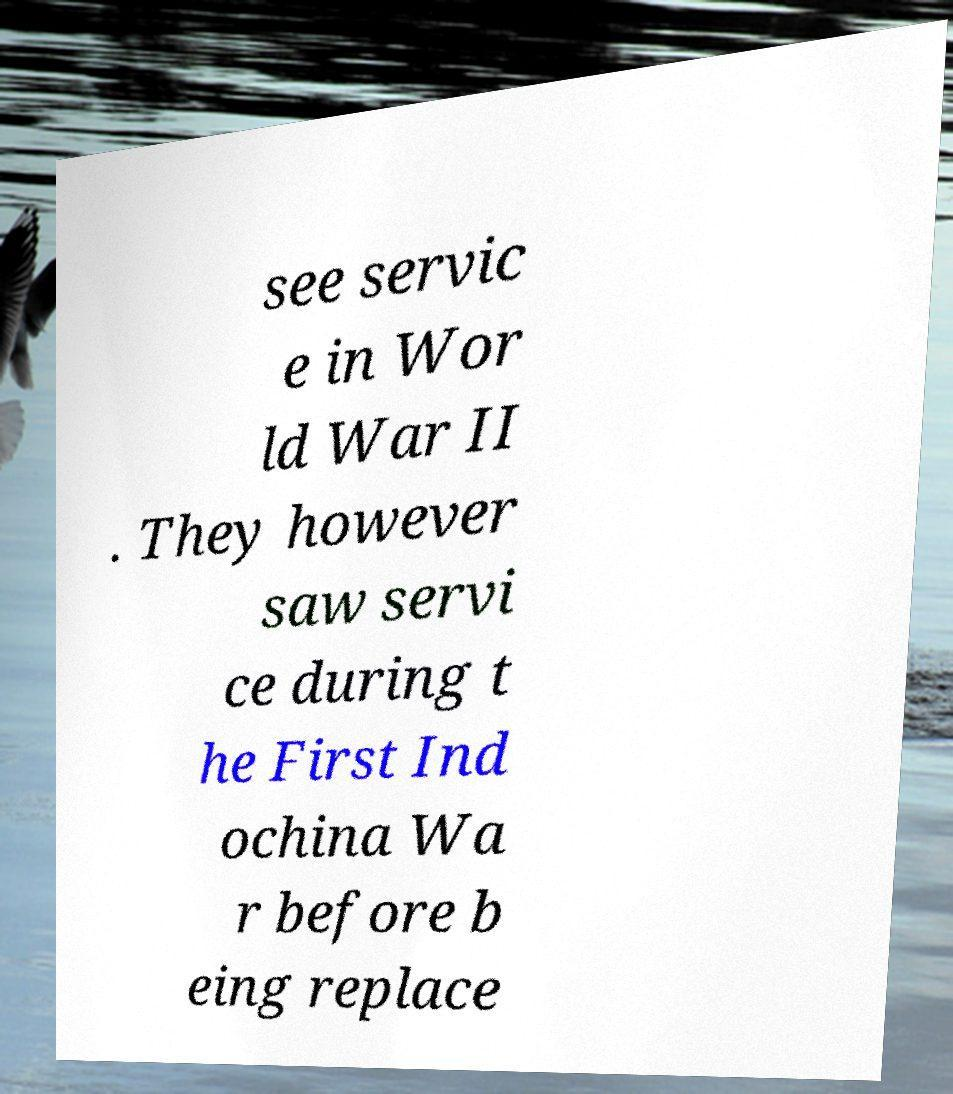Please identify and transcribe the text found in this image. see servic e in Wor ld War II . They however saw servi ce during t he First Ind ochina Wa r before b eing replace 